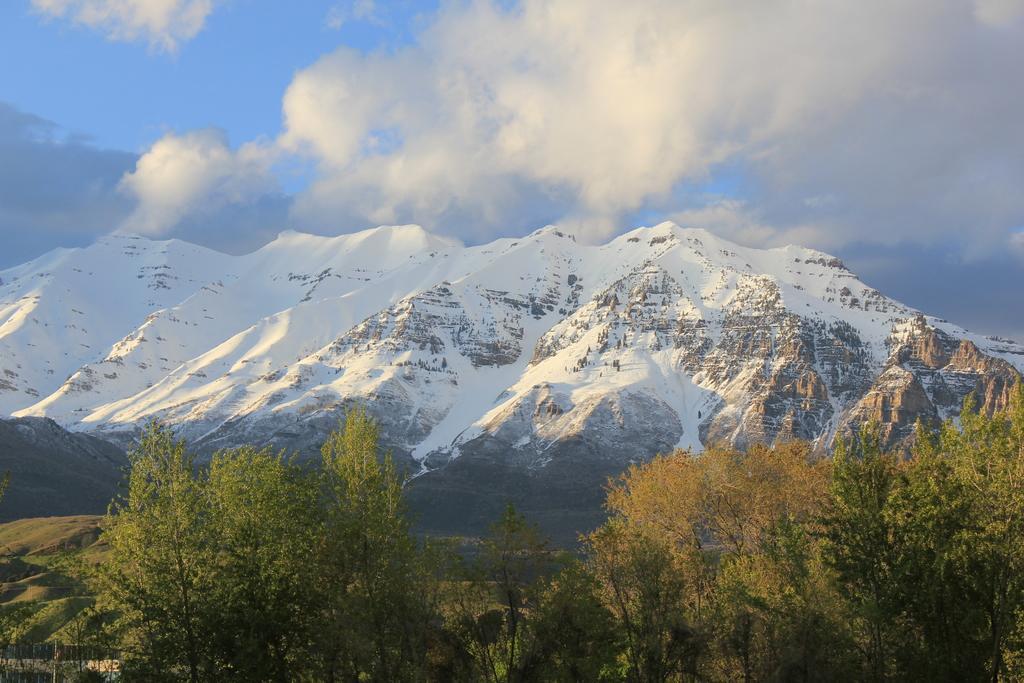In one or two sentences, can you explain what this image depicts? In this image I can see trees in green color, background I can see mountains and the sky is in white and blue color. 